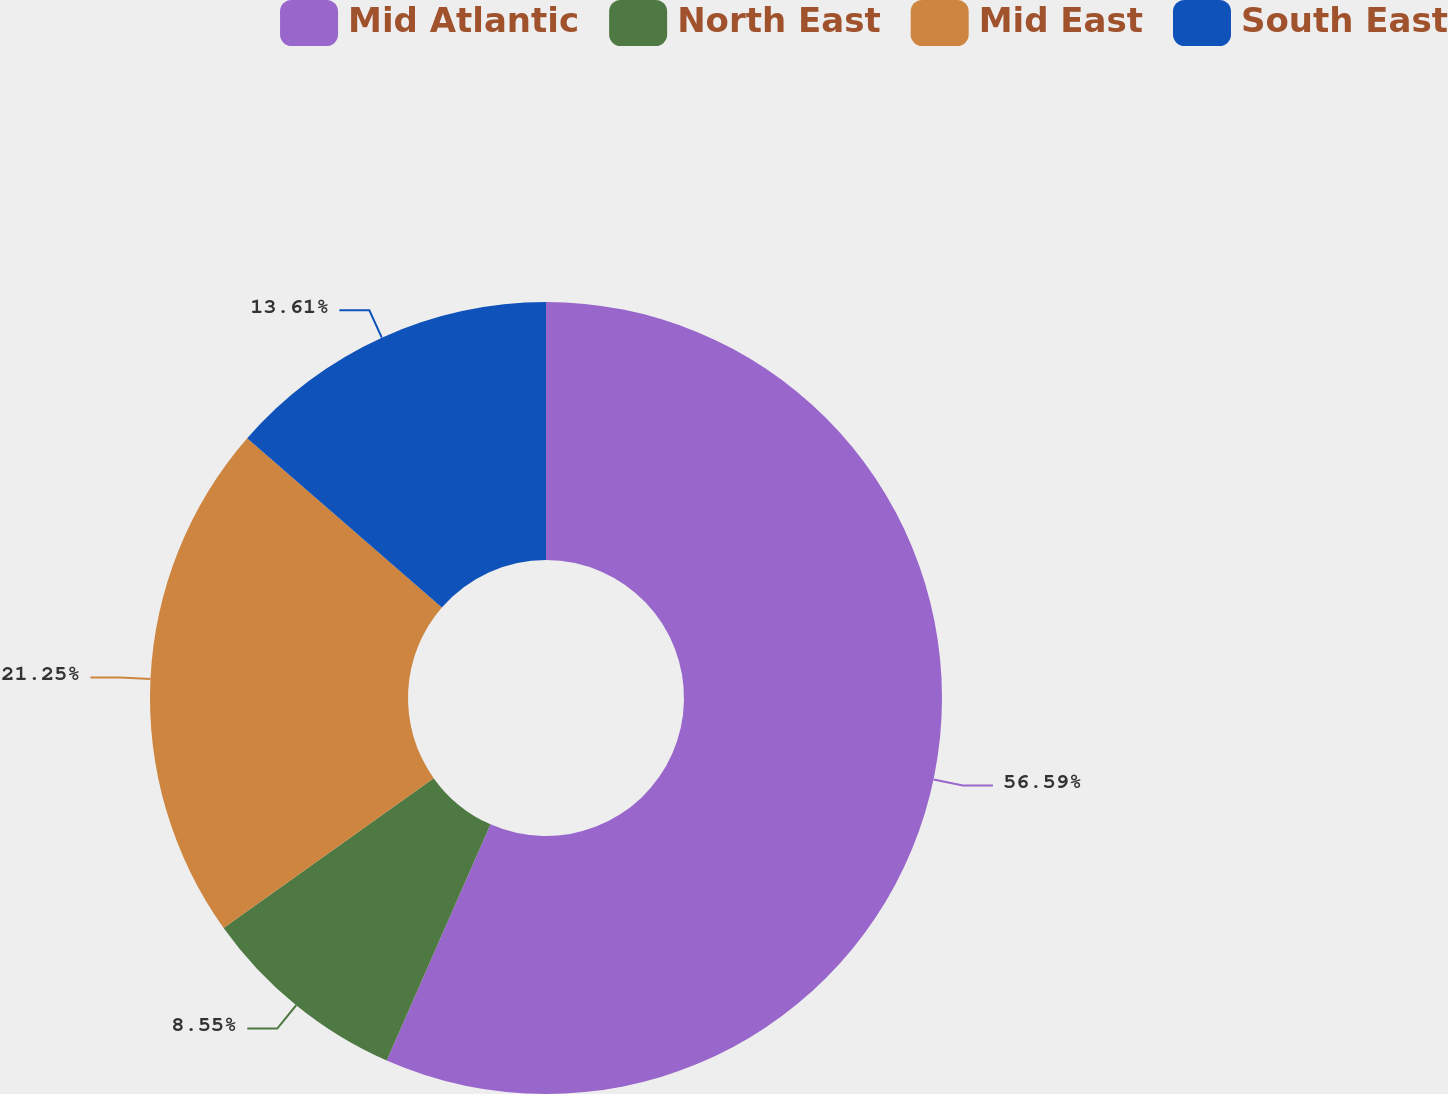<chart> <loc_0><loc_0><loc_500><loc_500><pie_chart><fcel>Mid Atlantic<fcel>North East<fcel>Mid East<fcel>South East<nl><fcel>56.59%<fcel>8.55%<fcel>21.25%<fcel>13.61%<nl></chart> 